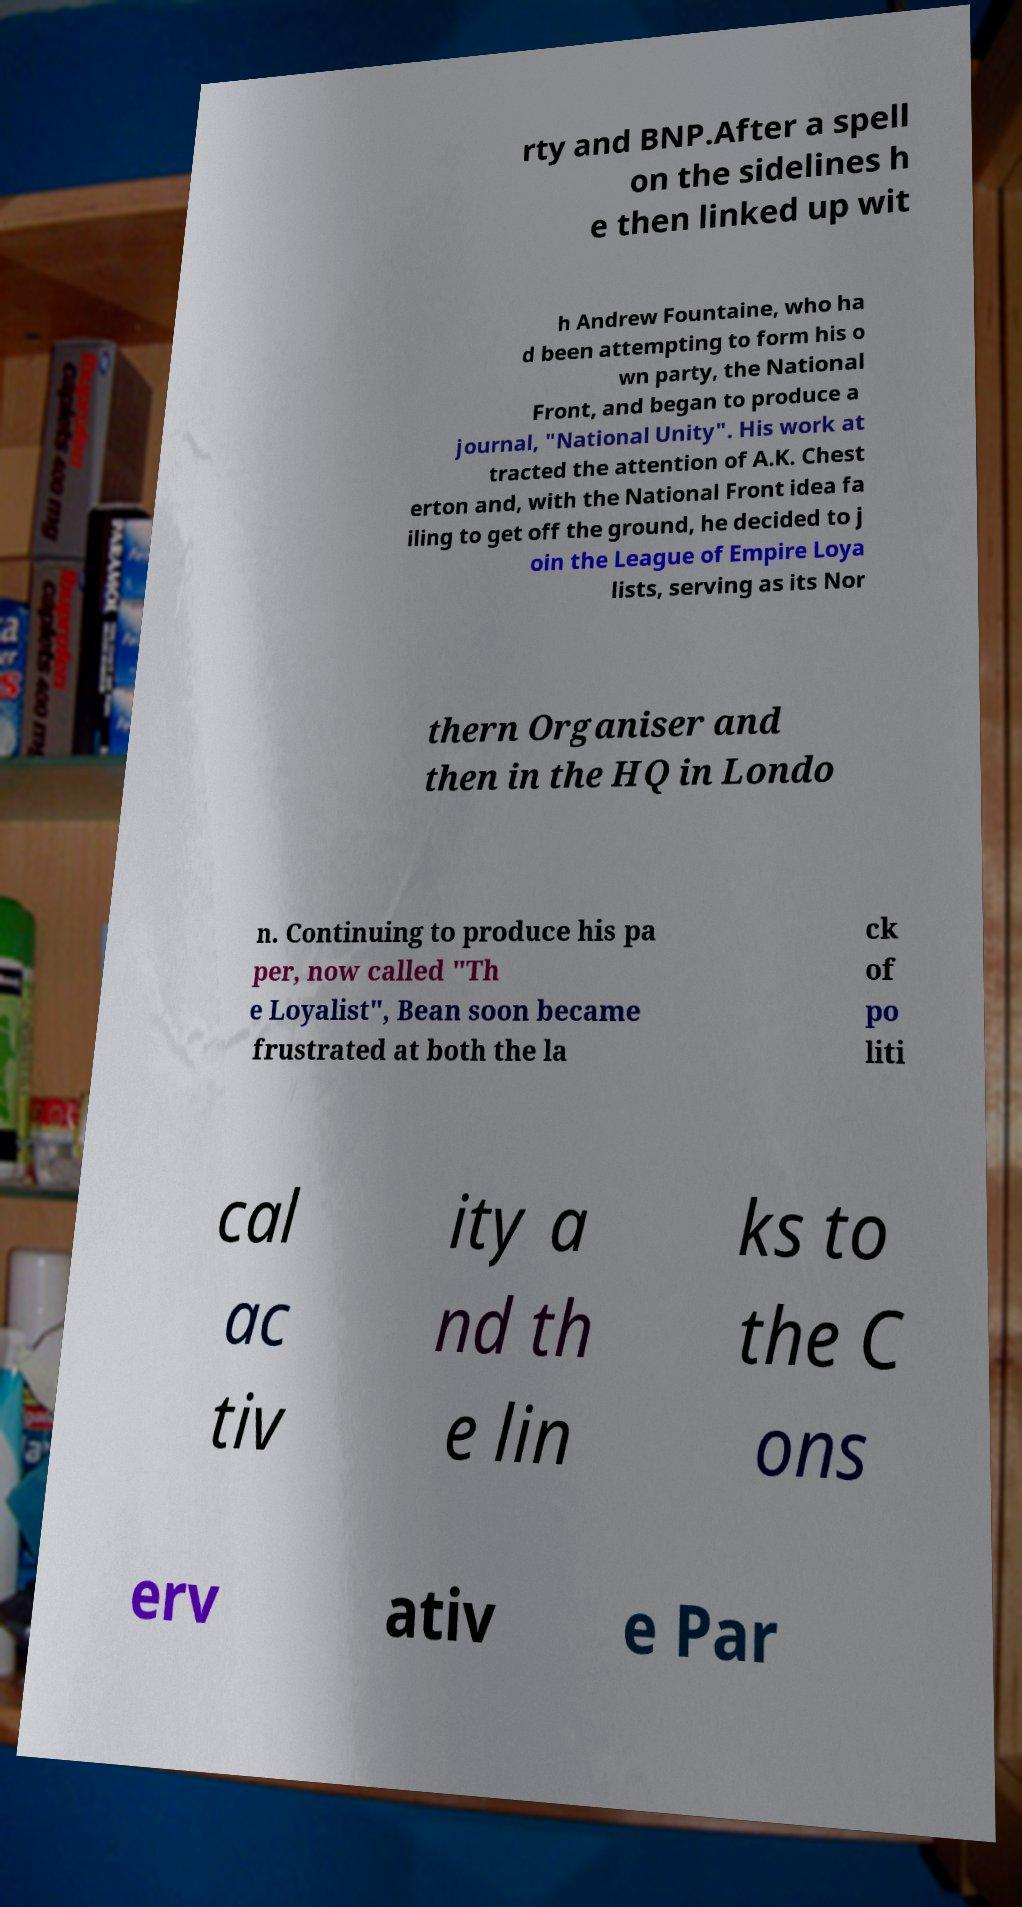Please read and relay the text visible in this image. What does it say? rty and BNP.After a spell on the sidelines h e then linked up wit h Andrew Fountaine, who ha d been attempting to form his o wn party, the National Front, and began to produce a journal, "National Unity". His work at tracted the attention of A.K. Chest erton and, with the National Front idea fa iling to get off the ground, he decided to j oin the League of Empire Loya lists, serving as its Nor thern Organiser and then in the HQ in Londo n. Continuing to produce his pa per, now called "Th e Loyalist", Bean soon became frustrated at both the la ck of po liti cal ac tiv ity a nd th e lin ks to the C ons erv ativ e Par 